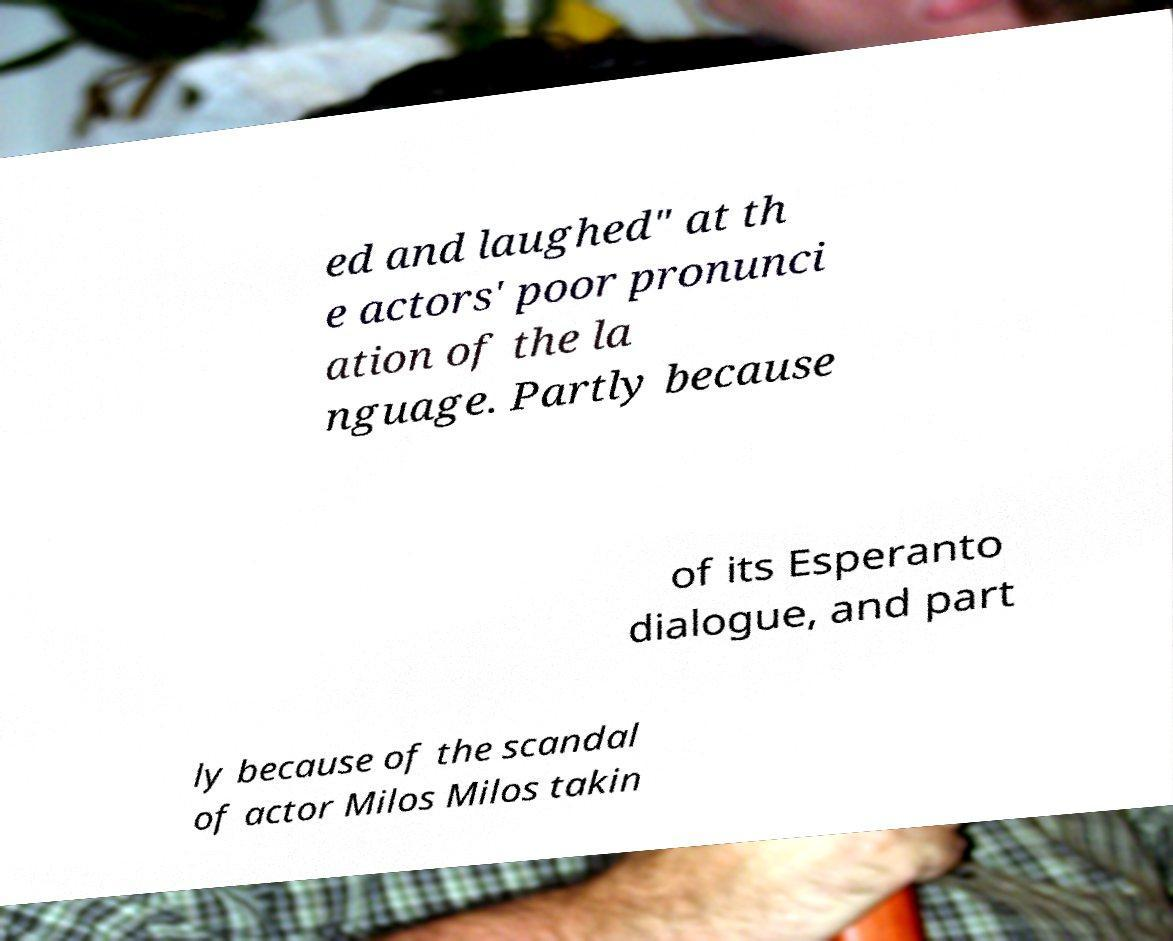Could you extract and type out the text from this image? ed and laughed" at th e actors' poor pronunci ation of the la nguage. Partly because of its Esperanto dialogue, and part ly because of the scandal of actor Milos Milos takin 